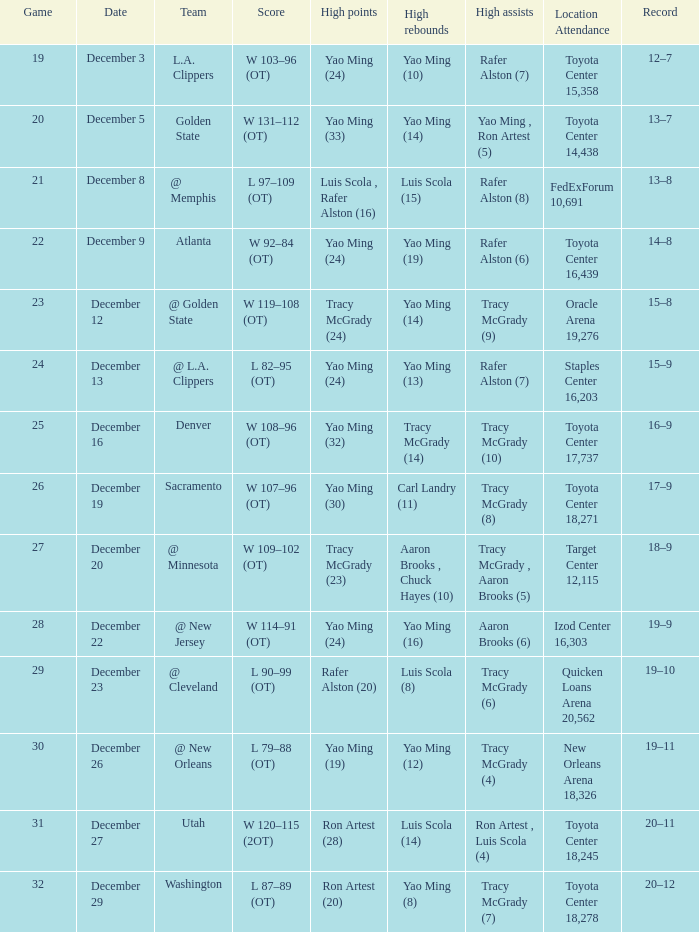When @ new orleans is the team who has the highest amount of rebounds? Yao Ming (12). Would you be able to parse every entry in this table? {'header': ['Game', 'Date', 'Team', 'Score', 'High points', 'High rebounds', 'High assists', 'Location Attendance', 'Record'], 'rows': [['19', 'December 3', 'L.A. Clippers', 'W 103–96 (OT)', 'Yao Ming (24)', 'Yao Ming (10)', 'Rafer Alston (7)', 'Toyota Center 15,358', '12–7'], ['20', 'December 5', 'Golden State', 'W 131–112 (OT)', 'Yao Ming (33)', 'Yao Ming (14)', 'Yao Ming , Ron Artest (5)', 'Toyota Center 14,438', '13–7'], ['21', 'December 8', '@ Memphis', 'L 97–109 (OT)', 'Luis Scola , Rafer Alston (16)', 'Luis Scola (15)', 'Rafer Alston (8)', 'FedExForum 10,691', '13–8'], ['22', 'December 9', 'Atlanta', 'W 92–84 (OT)', 'Yao Ming (24)', 'Yao Ming (19)', 'Rafer Alston (6)', 'Toyota Center 16,439', '14–8'], ['23', 'December 12', '@ Golden State', 'W 119–108 (OT)', 'Tracy McGrady (24)', 'Yao Ming (14)', 'Tracy McGrady (9)', 'Oracle Arena 19,276', '15–8'], ['24', 'December 13', '@ L.A. Clippers', 'L 82–95 (OT)', 'Yao Ming (24)', 'Yao Ming (13)', 'Rafer Alston (7)', 'Staples Center 16,203', '15–9'], ['25', 'December 16', 'Denver', 'W 108–96 (OT)', 'Yao Ming (32)', 'Tracy McGrady (14)', 'Tracy McGrady (10)', 'Toyota Center 17,737', '16–9'], ['26', 'December 19', 'Sacramento', 'W 107–96 (OT)', 'Yao Ming (30)', 'Carl Landry (11)', 'Tracy McGrady (8)', 'Toyota Center 18,271', '17–9'], ['27', 'December 20', '@ Minnesota', 'W 109–102 (OT)', 'Tracy McGrady (23)', 'Aaron Brooks , Chuck Hayes (10)', 'Tracy McGrady , Aaron Brooks (5)', 'Target Center 12,115', '18–9'], ['28', 'December 22', '@ New Jersey', 'W 114–91 (OT)', 'Yao Ming (24)', 'Yao Ming (16)', 'Aaron Brooks (6)', 'Izod Center 16,303', '19–9'], ['29', 'December 23', '@ Cleveland', 'L 90–99 (OT)', 'Rafer Alston (20)', 'Luis Scola (8)', 'Tracy McGrady (6)', 'Quicken Loans Arena 20,562', '19–10'], ['30', 'December 26', '@ New Orleans', 'L 79–88 (OT)', 'Yao Ming (19)', 'Yao Ming (12)', 'Tracy McGrady (4)', 'New Orleans Arena 18,326', '19–11'], ['31', 'December 27', 'Utah', 'W 120–115 (2OT)', 'Ron Artest (28)', 'Luis Scola (14)', 'Ron Artest , Luis Scola (4)', 'Toyota Center 18,245', '20–11'], ['32', 'December 29', 'Washington', 'L 87–89 (OT)', 'Ron Artest (20)', 'Yao Ming (8)', 'Tracy McGrady (7)', 'Toyota Center 18,278', '20–12']]} 